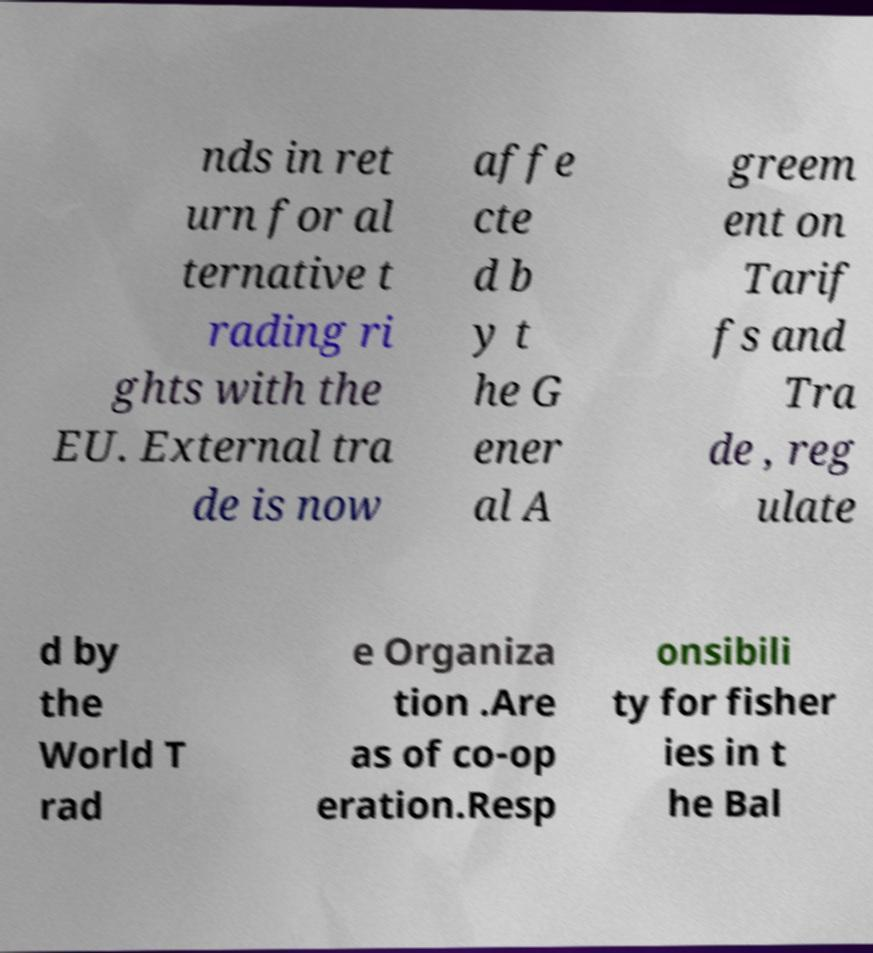Could you extract and type out the text from this image? nds in ret urn for al ternative t rading ri ghts with the EU. External tra de is now affe cte d b y t he G ener al A greem ent on Tarif fs and Tra de , reg ulate d by the World T rad e Organiza tion .Are as of co-op eration.Resp onsibili ty for fisher ies in t he Bal 